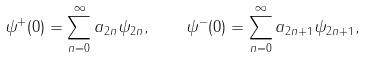Convert formula to latex. <formula><loc_0><loc_0><loc_500><loc_500>\psi ^ { + } ( 0 ) = \sum _ { n = 0 } ^ { \infty } a _ { 2 n } \psi _ { 2 n } , \quad \psi ^ { - } ( 0 ) = \sum _ { n = 0 } ^ { \infty } a _ { 2 n + 1 } \psi _ { 2 n + 1 } ,</formula> 